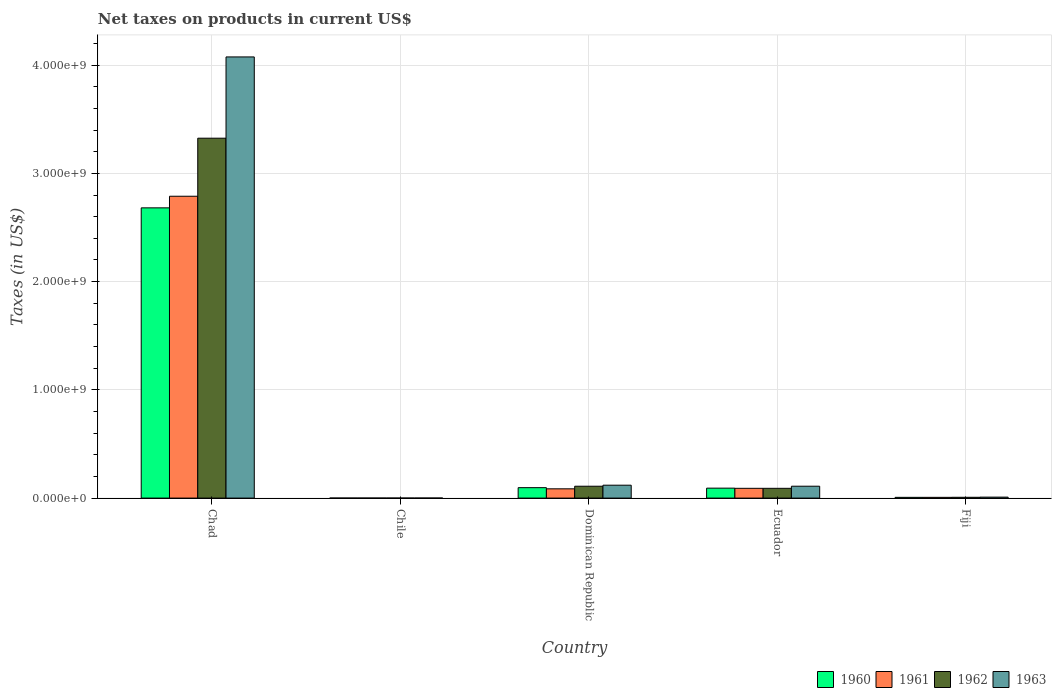How many different coloured bars are there?
Provide a short and direct response. 4. How many groups of bars are there?
Provide a short and direct response. 5. Are the number of bars per tick equal to the number of legend labels?
Make the answer very short. Yes. Are the number of bars on each tick of the X-axis equal?
Your answer should be compact. Yes. How many bars are there on the 3rd tick from the right?
Provide a succinct answer. 4. What is the label of the 1st group of bars from the left?
Provide a short and direct response. Chad. What is the net taxes on products in 1960 in Chile?
Provide a succinct answer. 2.02e+05. Across all countries, what is the maximum net taxes on products in 1961?
Provide a succinct answer. 2.79e+09. Across all countries, what is the minimum net taxes on products in 1961?
Provide a succinct answer. 2.53e+05. In which country was the net taxes on products in 1963 maximum?
Make the answer very short. Chad. What is the total net taxes on products in 1960 in the graph?
Ensure brevity in your answer.  2.88e+09. What is the difference between the net taxes on products in 1962 in Chad and that in Dominican Republic?
Offer a terse response. 3.22e+09. What is the difference between the net taxes on products in 1962 in Chile and the net taxes on products in 1960 in Ecuador?
Your answer should be very brief. -9.16e+07. What is the average net taxes on products in 1963 per country?
Your answer should be compact. 8.63e+08. What is the difference between the net taxes on products of/in 1963 and net taxes on products of/in 1961 in Dominican Republic?
Your answer should be very brief. 3.36e+07. In how many countries, is the net taxes on products in 1961 greater than 2200000000 US$?
Provide a short and direct response. 1. What is the ratio of the net taxes on products in 1963 in Dominican Republic to that in Ecuador?
Provide a short and direct response. 1.09. Is the difference between the net taxes on products in 1963 in Chad and Ecuador greater than the difference between the net taxes on products in 1961 in Chad and Ecuador?
Your answer should be very brief. Yes. What is the difference between the highest and the second highest net taxes on products in 1962?
Ensure brevity in your answer.  -3.22e+09. What is the difference between the highest and the lowest net taxes on products in 1960?
Your response must be concise. 2.68e+09. In how many countries, is the net taxes on products in 1961 greater than the average net taxes on products in 1961 taken over all countries?
Ensure brevity in your answer.  1. What does the 2nd bar from the left in Fiji represents?
Keep it short and to the point. 1961. What does the 4th bar from the right in Dominican Republic represents?
Offer a terse response. 1960. Are all the bars in the graph horizontal?
Keep it short and to the point. No. How many countries are there in the graph?
Provide a succinct answer. 5. Does the graph contain grids?
Your answer should be very brief. Yes. What is the title of the graph?
Provide a succinct answer. Net taxes on products in current US$. Does "1980" appear as one of the legend labels in the graph?
Your answer should be compact. No. What is the label or title of the X-axis?
Ensure brevity in your answer.  Country. What is the label or title of the Y-axis?
Provide a succinct answer. Taxes (in US$). What is the Taxes (in US$) of 1960 in Chad?
Your response must be concise. 2.68e+09. What is the Taxes (in US$) of 1961 in Chad?
Your response must be concise. 2.79e+09. What is the Taxes (in US$) of 1962 in Chad?
Your answer should be very brief. 3.32e+09. What is the Taxes (in US$) in 1963 in Chad?
Make the answer very short. 4.08e+09. What is the Taxes (in US$) in 1960 in Chile?
Make the answer very short. 2.02e+05. What is the Taxes (in US$) in 1961 in Chile?
Offer a very short reply. 2.53e+05. What is the Taxes (in US$) in 1962 in Chile?
Make the answer very short. 2.53e+05. What is the Taxes (in US$) in 1963 in Chile?
Give a very brief answer. 3.54e+05. What is the Taxes (in US$) in 1960 in Dominican Republic?
Ensure brevity in your answer.  9.64e+07. What is the Taxes (in US$) in 1961 in Dominican Republic?
Your answer should be compact. 8.56e+07. What is the Taxes (in US$) of 1962 in Dominican Republic?
Your answer should be compact. 1.10e+08. What is the Taxes (in US$) of 1963 in Dominican Republic?
Provide a succinct answer. 1.19e+08. What is the Taxes (in US$) of 1960 in Ecuador?
Give a very brief answer. 9.19e+07. What is the Taxes (in US$) of 1961 in Ecuador?
Keep it short and to the point. 9.02e+07. What is the Taxes (in US$) of 1962 in Ecuador?
Make the answer very short. 9.02e+07. What is the Taxes (in US$) of 1963 in Ecuador?
Provide a succinct answer. 1.10e+08. What is the Taxes (in US$) of 1960 in Fiji?
Your response must be concise. 6.80e+06. What is the Taxes (in US$) of 1961 in Fiji?
Offer a terse response. 6.80e+06. What is the Taxes (in US$) in 1962 in Fiji?
Offer a terse response. 7.40e+06. What is the Taxes (in US$) of 1963 in Fiji?
Make the answer very short. 8.90e+06. Across all countries, what is the maximum Taxes (in US$) in 1960?
Your answer should be very brief. 2.68e+09. Across all countries, what is the maximum Taxes (in US$) of 1961?
Provide a short and direct response. 2.79e+09. Across all countries, what is the maximum Taxes (in US$) of 1962?
Give a very brief answer. 3.32e+09. Across all countries, what is the maximum Taxes (in US$) of 1963?
Provide a succinct answer. 4.08e+09. Across all countries, what is the minimum Taxes (in US$) in 1960?
Provide a short and direct response. 2.02e+05. Across all countries, what is the minimum Taxes (in US$) in 1961?
Keep it short and to the point. 2.53e+05. Across all countries, what is the minimum Taxes (in US$) in 1962?
Your answer should be very brief. 2.53e+05. Across all countries, what is the minimum Taxes (in US$) of 1963?
Keep it short and to the point. 3.54e+05. What is the total Taxes (in US$) in 1960 in the graph?
Give a very brief answer. 2.88e+09. What is the total Taxes (in US$) of 1961 in the graph?
Give a very brief answer. 2.97e+09. What is the total Taxes (in US$) in 1962 in the graph?
Offer a very short reply. 3.53e+09. What is the total Taxes (in US$) of 1963 in the graph?
Ensure brevity in your answer.  4.31e+09. What is the difference between the Taxes (in US$) in 1960 in Chad and that in Chile?
Ensure brevity in your answer.  2.68e+09. What is the difference between the Taxes (in US$) of 1961 in Chad and that in Chile?
Your response must be concise. 2.79e+09. What is the difference between the Taxes (in US$) in 1962 in Chad and that in Chile?
Make the answer very short. 3.32e+09. What is the difference between the Taxes (in US$) in 1963 in Chad and that in Chile?
Your answer should be compact. 4.08e+09. What is the difference between the Taxes (in US$) in 1960 in Chad and that in Dominican Republic?
Provide a short and direct response. 2.58e+09. What is the difference between the Taxes (in US$) in 1961 in Chad and that in Dominican Republic?
Offer a terse response. 2.70e+09. What is the difference between the Taxes (in US$) of 1962 in Chad and that in Dominican Republic?
Ensure brevity in your answer.  3.22e+09. What is the difference between the Taxes (in US$) of 1963 in Chad and that in Dominican Republic?
Make the answer very short. 3.96e+09. What is the difference between the Taxes (in US$) of 1960 in Chad and that in Ecuador?
Keep it short and to the point. 2.59e+09. What is the difference between the Taxes (in US$) in 1961 in Chad and that in Ecuador?
Ensure brevity in your answer.  2.70e+09. What is the difference between the Taxes (in US$) of 1962 in Chad and that in Ecuador?
Your answer should be very brief. 3.23e+09. What is the difference between the Taxes (in US$) in 1963 in Chad and that in Ecuador?
Offer a terse response. 3.97e+09. What is the difference between the Taxes (in US$) in 1960 in Chad and that in Fiji?
Offer a terse response. 2.67e+09. What is the difference between the Taxes (in US$) in 1961 in Chad and that in Fiji?
Give a very brief answer. 2.78e+09. What is the difference between the Taxes (in US$) of 1962 in Chad and that in Fiji?
Your answer should be very brief. 3.32e+09. What is the difference between the Taxes (in US$) of 1963 in Chad and that in Fiji?
Give a very brief answer. 4.07e+09. What is the difference between the Taxes (in US$) in 1960 in Chile and that in Dominican Republic?
Ensure brevity in your answer.  -9.62e+07. What is the difference between the Taxes (in US$) in 1961 in Chile and that in Dominican Republic?
Your response must be concise. -8.53e+07. What is the difference between the Taxes (in US$) of 1962 in Chile and that in Dominican Republic?
Provide a short and direct response. -1.09e+08. What is the difference between the Taxes (in US$) of 1963 in Chile and that in Dominican Republic?
Your response must be concise. -1.19e+08. What is the difference between the Taxes (in US$) in 1960 in Chile and that in Ecuador?
Your response must be concise. -9.17e+07. What is the difference between the Taxes (in US$) of 1961 in Chile and that in Ecuador?
Your answer should be compact. -9.00e+07. What is the difference between the Taxes (in US$) of 1962 in Chile and that in Ecuador?
Ensure brevity in your answer.  -9.00e+07. What is the difference between the Taxes (in US$) of 1963 in Chile and that in Ecuador?
Offer a very short reply. -1.09e+08. What is the difference between the Taxes (in US$) in 1960 in Chile and that in Fiji?
Keep it short and to the point. -6.60e+06. What is the difference between the Taxes (in US$) of 1961 in Chile and that in Fiji?
Your answer should be very brief. -6.55e+06. What is the difference between the Taxes (in US$) of 1962 in Chile and that in Fiji?
Provide a succinct answer. -7.15e+06. What is the difference between the Taxes (in US$) of 1963 in Chile and that in Fiji?
Ensure brevity in your answer.  -8.55e+06. What is the difference between the Taxes (in US$) of 1960 in Dominican Republic and that in Ecuador?
Provide a succinct answer. 4.51e+06. What is the difference between the Taxes (in US$) of 1961 in Dominican Republic and that in Ecuador?
Offer a terse response. -4.62e+06. What is the difference between the Taxes (in US$) of 1962 in Dominican Republic and that in Ecuador?
Your answer should be compact. 1.94e+07. What is the difference between the Taxes (in US$) of 1963 in Dominican Republic and that in Ecuador?
Give a very brief answer. 9.49e+06. What is the difference between the Taxes (in US$) in 1960 in Dominican Republic and that in Fiji?
Ensure brevity in your answer.  8.96e+07. What is the difference between the Taxes (in US$) in 1961 in Dominican Republic and that in Fiji?
Offer a terse response. 7.88e+07. What is the difference between the Taxes (in US$) in 1962 in Dominican Republic and that in Fiji?
Make the answer very short. 1.02e+08. What is the difference between the Taxes (in US$) in 1963 in Dominican Republic and that in Fiji?
Make the answer very short. 1.10e+08. What is the difference between the Taxes (in US$) of 1960 in Ecuador and that in Fiji?
Provide a succinct answer. 8.51e+07. What is the difference between the Taxes (in US$) in 1961 in Ecuador and that in Fiji?
Keep it short and to the point. 8.34e+07. What is the difference between the Taxes (in US$) of 1962 in Ecuador and that in Fiji?
Offer a very short reply. 8.28e+07. What is the difference between the Taxes (in US$) in 1963 in Ecuador and that in Fiji?
Your response must be concise. 1.01e+08. What is the difference between the Taxes (in US$) of 1960 in Chad and the Taxes (in US$) of 1961 in Chile?
Offer a terse response. 2.68e+09. What is the difference between the Taxes (in US$) in 1960 in Chad and the Taxes (in US$) in 1962 in Chile?
Provide a succinct answer. 2.68e+09. What is the difference between the Taxes (in US$) in 1960 in Chad and the Taxes (in US$) in 1963 in Chile?
Offer a very short reply. 2.68e+09. What is the difference between the Taxes (in US$) in 1961 in Chad and the Taxes (in US$) in 1962 in Chile?
Ensure brevity in your answer.  2.79e+09. What is the difference between the Taxes (in US$) in 1961 in Chad and the Taxes (in US$) in 1963 in Chile?
Keep it short and to the point. 2.79e+09. What is the difference between the Taxes (in US$) in 1962 in Chad and the Taxes (in US$) in 1963 in Chile?
Give a very brief answer. 3.32e+09. What is the difference between the Taxes (in US$) of 1960 in Chad and the Taxes (in US$) of 1961 in Dominican Republic?
Offer a terse response. 2.60e+09. What is the difference between the Taxes (in US$) in 1960 in Chad and the Taxes (in US$) in 1962 in Dominican Republic?
Offer a terse response. 2.57e+09. What is the difference between the Taxes (in US$) in 1960 in Chad and the Taxes (in US$) in 1963 in Dominican Republic?
Give a very brief answer. 2.56e+09. What is the difference between the Taxes (in US$) in 1961 in Chad and the Taxes (in US$) in 1962 in Dominican Republic?
Provide a succinct answer. 2.68e+09. What is the difference between the Taxes (in US$) of 1961 in Chad and the Taxes (in US$) of 1963 in Dominican Republic?
Offer a terse response. 2.67e+09. What is the difference between the Taxes (in US$) in 1962 in Chad and the Taxes (in US$) in 1963 in Dominican Republic?
Offer a terse response. 3.21e+09. What is the difference between the Taxes (in US$) of 1960 in Chad and the Taxes (in US$) of 1961 in Ecuador?
Give a very brief answer. 2.59e+09. What is the difference between the Taxes (in US$) of 1960 in Chad and the Taxes (in US$) of 1962 in Ecuador?
Give a very brief answer. 2.59e+09. What is the difference between the Taxes (in US$) in 1960 in Chad and the Taxes (in US$) in 1963 in Ecuador?
Keep it short and to the point. 2.57e+09. What is the difference between the Taxes (in US$) in 1961 in Chad and the Taxes (in US$) in 1962 in Ecuador?
Provide a short and direct response. 2.70e+09. What is the difference between the Taxes (in US$) in 1961 in Chad and the Taxes (in US$) in 1963 in Ecuador?
Provide a succinct answer. 2.68e+09. What is the difference between the Taxes (in US$) in 1962 in Chad and the Taxes (in US$) in 1963 in Ecuador?
Your response must be concise. 3.22e+09. What is the difference between the Taxes (in US$) of 1960 in Chad and the Taxes (in US$) of 1961 in Fiji?
Offer a terse response. 2.67e+09. What is the difference between the Taxes (in US$) of 1960 in Chad and the Taxes (in US$) of 1962 in Fiji?
Make the answer very short. 2.67e+09. What is the difference between the Taxes (in US$) of 1960 in Chad and the Taxes (in US$) of 1963 in Fiji?
Your answer should be compact. 2.67e+09. What is the difference between the Taxes (in US$) of 1961 in Chad and the Taxes (in US$) of 1962 in Fiji?
Provide a succinct answer. 2.78e+09. What is the difference between the Taxes (in US$) in 1961 in Chad and the Taxes (in US$) in 1963 in Fiji?
Your answer should be compact. 2.78e+09. What is the difference between the Taxes (in US$) of 1962 in Chad and the Taxes (in US$) of 1963 in Fiji?
Your answer should be very brief. 3.32e+09. What is the difference between the Taxes (in US$) in 1960 in Chile and the Taxes (in US$) in 1961 in Dominican Republic?
Ensure brevity in your answer.  -8.54e+07. What is the difference between the Taxes (in US$) of 1960 in Chile and the Taxes (in US$) of 1962 in Dominican Republic?
Your answer should be compact. -1.09e+08. What is the difference between the Taxes (in US$) in 1960 in Chile and the Taxes (in US$) in 1963 in Dominican Republic?
Give a very brief answer. -1.19e+08. What is the difference between the Taxes (in US$) in 1961 in Chile and the Taxes (in US$) in 1962 in Dominican Republic?
Give a very brief answer. -1.09e+08. What is the difference between the Taxes (in US$) of 1961 in Chile and the Taxes (in US$) of 1963 in Dominican Republic?
Provide a succinct answer. -1.19e+08. What is the difference between the Taxes (in US$) in 1962 in Chile and the Taxes (in US$) in 1963 in Dominican Republic?
Make the answer very short. -1.19e+08. What is the difference between the Taxes (in US$) in 1960 in Chile and the Taxes (in US$) in 1961 in Ecuador?
Ensure brevity in your answer.  -9.00e+07. What is the difference between the Taxes (in US$) of 1960 in Chile and the Taxes (in US$) of 1962 in Ecuador?
Offer a terse response. -9.00e+07. What is the difference between the Taxes (in US$) in 1960 in Chile and the Taxes (in US$) in 1963 in Ecuador?
Provide a succinct answer. -1.10e+08. What is the difference between the Taxes (in US$) in 1961 in Chile and the Taxes (in US$) in 1962 in Ecuador?
Give a very brief answer. -9.00e+07. What is the difference between the Taxes (in US$) in 1961 in Chile and the Taxes (in US$) in 1963 in Ecuador?
Give a very brief answer. -1.09e+08. What is the difference between the Taxes (in US$) in 1962 in Chile and the Taxes (in US$) in 1963 in Ecuador?
Make the answer very short. -1.09e+08. What is the difference between the Taxes (in US$) in 1960 in Chile and the Taxes (in US$) in 1961 in Fiji?
Your response must be concise. -6.60e+06. What is the difference between the Taxes (in US$) of 1960 in Chile and the Taxes (in US$) of 1962 in Fiji?
Your answer should be very brief. -7.20e+06. What is the difference between the Taxes (in US$) in 1960 in Chile and the Taxes (in US$) in 1963 in Fiji?
Provide a succinct answer. -8.70e+06. What is the difference between the Taxes (in US$) of 1961 in Chile and the Taxes (in US$) of 1962 in Fiji?
Your answer should be compact. -7.15e+06. What is the difference between the Taxes (in US$) in 1961 in Chile and the Taxes (in US$) in 1963 in Fiji?
Offer a terse response. -8.65e+06. What is the difference between the Taxes (in US$) of 1962 in Chile and the Taxes (in US$) of 1963 in Fiji?
Offer a terse response. -8.65e+06. What is the difference between the Taxes (in US$) of 1960 in Dominican Republic and the Taxes (in US$) of 1961 in Ecuador?
Give a very brief answer. 6.18e+06. What is the difference between the Taxes (in US$) of 1960 in Dominican Republic and the Taxes (in US$) of 1962 in Ecuador?
Your answer should be very brief. 6.18e+06. What is the difference between the Taxes (in US$) in 1960 in Dominican Republic and the Taxes (in US$) in 1963 in Ecuador?
Offer a terse response. -1.33e+07. What is the difference between the Taxes (in US$) in 1961 in Dominican Republic and the Taxes (in US$) in 1962 in Ecuador?
Your response must be concise. -4.62e+06. What is the difference between the Taxes (in US$) of 1961 in Dominican Republic and the Taxes (in US$) of 1963 in Ecuador?
Ensure brevity in your answer.  -2.41e+07. What is the difference between the Taxes (in US$) of 1962 in Dominican Republic and the Taxes (in US$) of 1963 in Ecuador?
Your answer should be compact. -1.11e+05. What is the difference between the Taxes (in US$) in 1960 in Dominican Republic and the Taxes (in US$) in 1961 in Fiji?
Your answer should be very brief. 8.96e+07. What is the difference between the Taxes (in US$) of 1960 in Dominican Republic and the Taxes (in US$) of 1962 in Fiji?
Your answer should be compact. 8.90e+07. What is the difference between the Taxes (in US$) of 1960 in Dominican Republic and the Taxes (in US$) of 1963 in Fiji?
Make the answer very short. 8.75e+07. What is the difference between the Taxes (in US$) of 1961 in Dominican Republic and the Taxes (in US$) of 1962 in Fiji?
Provide a short and direct response. 7.82e+07. What is the difference between the Taxes (in US$) in 1961 in Dominican Republic and the Taxes (in US$) in 1963 in Fiji?
Ensure brevity in your answer.  7.67e+07. What is the difference between the Taxes (in US$) in 1962 in Dominican Republic and the Taxes (in US$) in 1963 in Fiji?
Your answer should be compact. 1.01e+08. What is the difference between the Taxes (in US$) in 1960 in Ecuador and the Taxes (in US$) in 1961 in Fiji?
Ensure brevity in your answer.  8.51e+07. What is the difference between the Taxes (in US$) in 1960 in Ecuador and the Taxes (in US$) in 1962 in Fiji?
Your answer should be compact. 8.45e+07. What is the difference between the Taxes (in US$) of 1960 in Ecuador and the Taxes (in US$) of 1963 in Fiji?
Provide a short and direct response. 8.30e+07. What is the difference between the Taxes (in US$) in 1961 in Ecuador and the Taxes (in US$) in 1962 in Fiji?
Ensure brevity in your answer.  8.28e+07. What is the difference between the Taxes (in US$) of 1961 in Ecuador and the Taxes (in US$) of 1963 in Fiji?
Give a very brief answer. 8.13e+07. What is the difference between the Taxes (in US$) of 1962 in Ecuador and the Taxes (in US$) of 1963 in Fiji?
Offer a terse response. 8.13e+07. What is the average Taxes (in US$) of 1960 per country?
Make the answer very short. 5.75e+08. What is the average Taxes (in US$) in 1961 per country?
Give a very brief answer. 5.94e+08. What is the average Taxes (in US$) of 1962 per country?
Your response must be concise. 7.06e+08. What is the average Taxes (in US$) of 1963 per country?
Make the answer very short. 8.63e+08. What is the difference between the Taxes (in US$) in 1960 and Taxes (in US$) in 1961 in Chad?
Make the answer very short. -1.07e+08. What is the difference between the Taxes (in US$) of 1960 and Taxes (in US$) of 1962 in Chad?
Offer a very short reply. -6.44e+08. What is the difference between the Taxes (in US$) in 1960 and Taxes (in US$) in 1963 in Chad?
Keep it short and to the point. -1.39e+09. What is the difference between the Taxes (in US$) of 1961 and Taxes (in US$) of 1962 in Chad?
Provide a short and direct response. -5.36e+08. What is the difference between the Taxes (in US$) in 1961 and Taxes (in US$) in 1963 in Chad?
Give a very brief answer. -1.29e+09. What is the difference between the Taxes (in US$) of 1962 and Taxes (in US$) of 1963 in Chad?
Offer a very short reply. -7.51e+08. What is the difference between the Taxes (in US$) of 1960 and Taxes (in US$) of 1961 in Chile?
Your answer should be compact. -5.06e+04. What is the difference between the Taxes (in US$) of 1960 and Taxes (in US$) of 1962 in Chile?
Give a very brief answer. -5.06e+04. What is the difference between the Taxes (in US$) of 1960 and Taxes (in US$) of 1963 in Chile?
Keep it short and to the point. -1.52e+05. What is the difference between the Taxes (in US$) of 1961 and Taxes (in US$) of 1962 in Chile?
Offer a terse response. 0. What is the difference between the Taxes (in US$) in 1961 and Taxes (in US$) in 1963 in Chile?
Give a very brief answer. -1.01e+05. What is the difference between the Taxes (in US$) of 1962 and Taxes (in US$) of 1963 in Chile?
Ensure brevity in your answer.  -1.01e+05. What is the difference between the Taxes (in US$) of 1960 and Taxes (in US$) of 1961 in Dominican Republic?
Your response must be concise. 1.08e+07. What is the difference between the Taxes (in US$) of 1960 and Taxes (in US$) of 1962 in Dominican Republic?
Give a very brief answer. -1.32e+07. What is the difference between the Taxes (in US$) in 1960 and Taxes (in US$) in 1963 in Dominican Republic?
Keep it short and to the point. -2.28e+07. What is the difference between the Taxes (in US$) in 1961 and Taxes (in US$) in 1962 in Dominican Republic?
Your response must be concise. -2.40e+07. What is the difference between the Taxes (in US$) in 1961 and Taxes (in US$) in 1963 in Dominican Republic?
Offer a terse response. -3.36e+07. What is the difference between the Taxes (in US$) in 1962 and Taxes (in US$) in 1963 in Dominican Republic?
Make the answer very short. -9.60e+06. What is the difference between the Taxes (in US$) in 1960 and Taxes (in US$) in 1961 in Ecuador?
Your response must be concise. 1.67e+06. What is the difference between the Taxes (in US$) of 1960 and Taxes (in US$) of 1962 in Ecuador?
Your answer should be very brief. 1.67e+06. What is the difference between the Taxes (in US$) in 1960 and Taxes (in US$) in 1963 in Ecuador?
Ensure brevity in your answer.  -1.78e+07. What is the difference between the Taxes (in US$) in 1961 and Taxes (in US$) in 1962 in Ecuador?
Make the answer very short. 0. What is the difference between the Taxes (in US$) in 1961 and Taxes (in US$) in 1963 in Ecuador?
Offer a very short reply. -1.95e+07. What is the difference between the Taxes (in US$) in 1962 and Taxes (in US$) in 1963 in Ecuador?
Provide a short and direct response. -1.95e+07. What is the difference between the Taxes (in US$) of 1960 and Taxes (in US$) of 1961 in Fiji?
Provide a short and direct response. 0. What is the difference between the Taxes (in US$) of 1960 and Taxes (in US$) of 1962 in Fiji?
Provide a short and direct response. -6.00e+05. What is the difference between the Taxes (in US$) in 1960 and Taxes (in US$) in 1963 in Fiji?
Your response must be concise. -2.10e+06. What is the difference between the Taxes (in US$) in 1961 and Taxes (in US$) in 1962 in Fiji?
Keep it short and to the point. -6.00e+05. What is the difference between the Taxes (in US$) in 1961 and Taxes (in US$) in 1963 in Fiji?
Offer a terse response. -2.10e+06. What is the difference between the Taxes (in US$) of 1962 and Taxes (in US$) of 1963 in Fiji?
Keep it short and to the point. -1.50e+06. What is the ratio of the Taxes (in US$) in 1960 in Chad to that in Chile?
Provide a short and direct response. 1.32e+04. What is the ratio of the Taxes (in US$) in 1961 in Chad to that in Chile?
Keep it short and to the point. 1.10e+04. What is the ratio of the Taxes (in US$) in 1962 in Chad to that in Chile?
Give a very brief answer. 1.31e+04. What is the ratio of the Taxes (in US$) in 1963 in Chad to that in Chile?
Ensure brevity in your answer.  1.15e+04. What is the ratio of the Taxes (in US$) in 1960 in Chad to that in Dominican Republic?
Give a very brief answer. 27.81. What is the ratio of the Taxes (in US$) of 1961 in Chad to that in Dominican Republic?
Keep it short and to the point. 32.58. What is the ratio of the Taxes (in US$) of 1962 in Chad to that in Dominican Republic?
Your response must be concise. 30.34. What is the ratio of the Taxes (in US$) in 1963 in Chad to that in Dominican Republic?
Keep it short and to the point. 34.19. What is the ratio of the Taxes (in US$) in 1960 in Chad to that in Ecuador?
Provide a short and direct response. 29.18. What is the ratio of the Taxes (in US$) of 1961 in Chad to that in Ecuador?
Offer a very short reply. 30.91. What is the ratio of the Taxes (in US$) in 1962 in Chad to that in Ecuador?
Offer a very short reply. 36.85. What is the ratio of the Taxes (in US$) of 1963 in Chad to that in Ecuador?
Your answer should be compact. 37.15. What is the ratio of the Taxes (in US$) of 1960 in Chad to that in Fiji?
Offer a very short reply. 394.3. What is the ratio of the Taxes (in US$) of 1961 in Chad to that in Fiji?
Provide a short and direct response. 410.08. What is the ratio of the Taxes (in US$) in 1962 in Chad to that in Fiji?
Your answer should be compact. 449.29. What is the ratio of the Taxes (in US$) of 1963 in Chad to that in Fiji?
Offer a very short reply. 457.92. What is the ratio of the Taxes (in US$) of 1960 in Chile to that in Dominican Republic?
Provide a short and direct response. 0. What is the ratio of the Taxes (in US$) of 1961 in Chile to that in Dominican Republic?
Your answer should be very brief. 0. What is the ratio of the Taxes (in US$) in 1962 in Chile to that in Dominican Republic?
Give a very brief answer. 0. What is the ratio of the Taxes (in US$) of 1963 in Chile to that in Dominican Republic?
Your response must be concise. 0. What is the ratio of the Taxes (in US$) of 1960 in Chile to that in Ecuador?
Provide a succinct answer. 0. What is the ratio of the Taxes (in US$) in 1961 in Chile to that in Ecuador?
Offer a very short reply. 0. What is the ratio of the Taxes (in US$) in 1962 in Chile to that in Ecuador?
Your answer should be very brief. 0. What is the ratio of the Taxes (in US$) in 1963 in Chile to that in Ecuador?
Make the answer very short. 0. What is the ratio of the Taxes (in US$) in 1960 in Chile to that in Fiji?
Your answer should be very brief. 0.03. What is the ratio of the Taxes (in US$) in 1961 in Chile to that in Fiji?
Ensure brevity in your answer.  0.04. What is the ratio of the Taxes (in US$) in 1962 in Chile to that in Fiji?
Offer a very short reply. 0.03. What is the ratio of the Taxes (in US$) in 1963 in Chile to that in Fiji?
Your answer should be compact. 0.04. What is the ratio of the Taxes (in US$) of 1960 in Dominican Republic to that in Ecuador?
Ensure brevity in your answer.  1.05. What is the ratio of the Taxes (in US$) of 1961 in Dominican Republic to that in Ecuador?
Make the answer very short. 0.95. What is the ratio of the Taxes (in US$) in 1962 in Dominican Republic to that in Ecuador?
Your answer should be very brief. 1.21. What is the ratio of the Taxes (in US$) in 1963 in Dominican Republic to that in Ecuador?
Your answer should be very brief. 1.09. What is the ratio of the Taxes (in US$) of 1960 in Dominican Republic to that in Fiji?
Your answer should be compact. 14.18. What is the ratio of the Taxes (in US$) of 1961 in Dominican Republic to that in Fiji?
Your answer should be very brief. 12.59. What is the ratio of the Taxes (in US$) in 1962 in Dominican Republic to that in Fiji?
Make the answer very short. 14.81. What is the ratio of the Taxes (in US$) of 1963 in Dominican Republic to that in Fiji?
Your answer should be compact. 13.39. What is the ratio of the Taxes (in US$) of 1960 in Ecuador to that in Fiji?
Provide a short and direct response. 13.51. What is the ratio of the Taxes (in US$) of 1961 in Ecuador to that in Fiji?
Provide a short and direct response. 13.27. What is the ratio of the Taxes (in US$) of 1962 in Ecuador to that in Fiji?
Your answer should be very brief. 12.19. What is the ratio of the Taxes (in US$) of 1963 in Ecuador to that in Fiji?
Provide a succinct answer. 12.33. What is the difference between the highest and the second highest Taxes (in US$) of 1960?
Provide a short and direct response. 2.58e+09. What is the difference between the highest and the second highest Taxes (in US$) of 1961?
Offer a terse response. 2.70e+09. What is the difference between the highest and the second highest Taxes (in US$) of 1962?
Your answer should be very brief. 3.22e+09. What is the difference between the highest and the second highest Taxes (in US$) in 1963?
Your response must be concise. 3.96e+09. What is the difference between the highest and the lowest Taxes (in US$) in 1960?
Your response must be concise. 2.68e+09. What is the difference between the highest and the lowest Taxes (in US$) in 1961?
Your answer should be compact. 2.79e+09. What is the difference between the highest and the lowest Taxes (in US$) of 1962?
Offer a very short reply. 3.32e+09. What is the difference between the highest and the lowest Taxes (in US$) in 1963?
Offer a very short reply. 4.08e+09. 